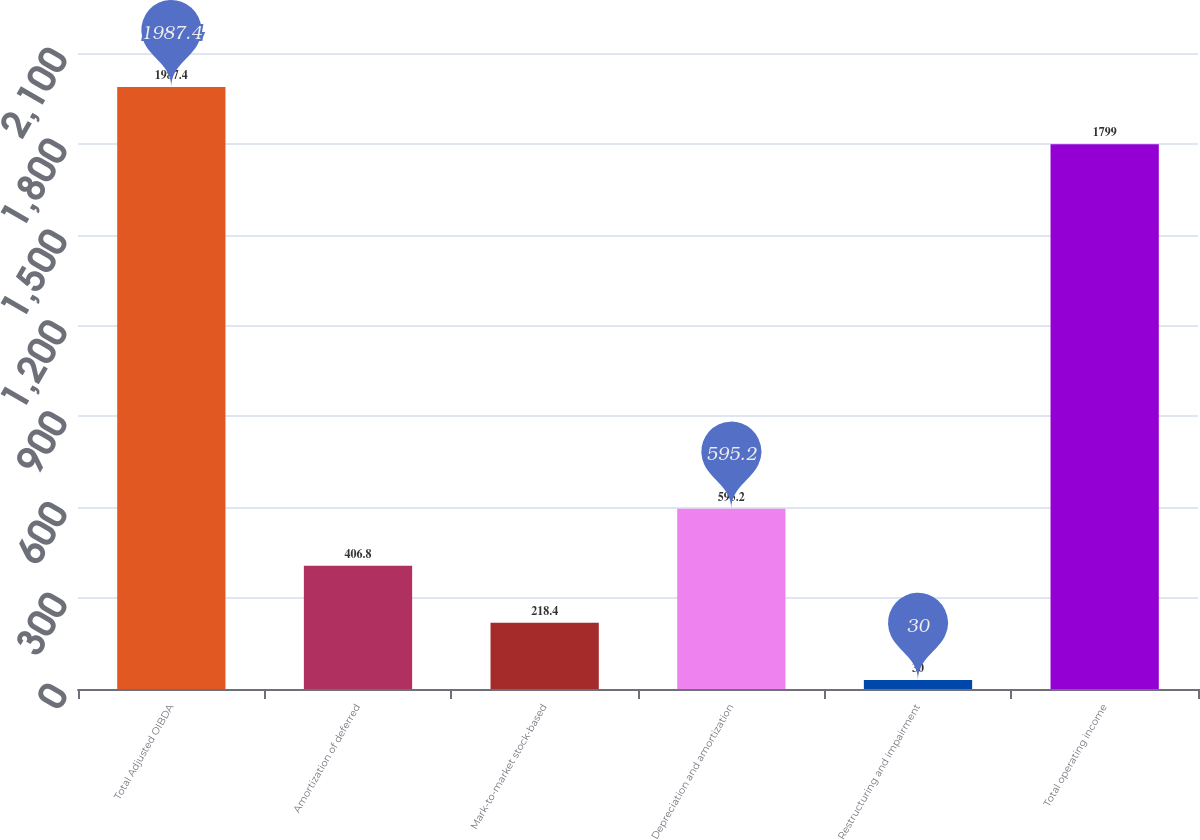<chart> <loc_0><loc_0><loc_500><loc_500><bar_chart><fcel>Total Adjusted OIBDA<fcel>Amortization of deferred<fcel>Mark-to-market stock-based<fcel>Depreciation and amortization<fcel>Restructuring and impairment<fcel>Total operating income<nl><fcel>1987.4<fcel>406.8<fcel>218.4<fcel>595.2<fcel>30<fcel>1799<nl></chart> 